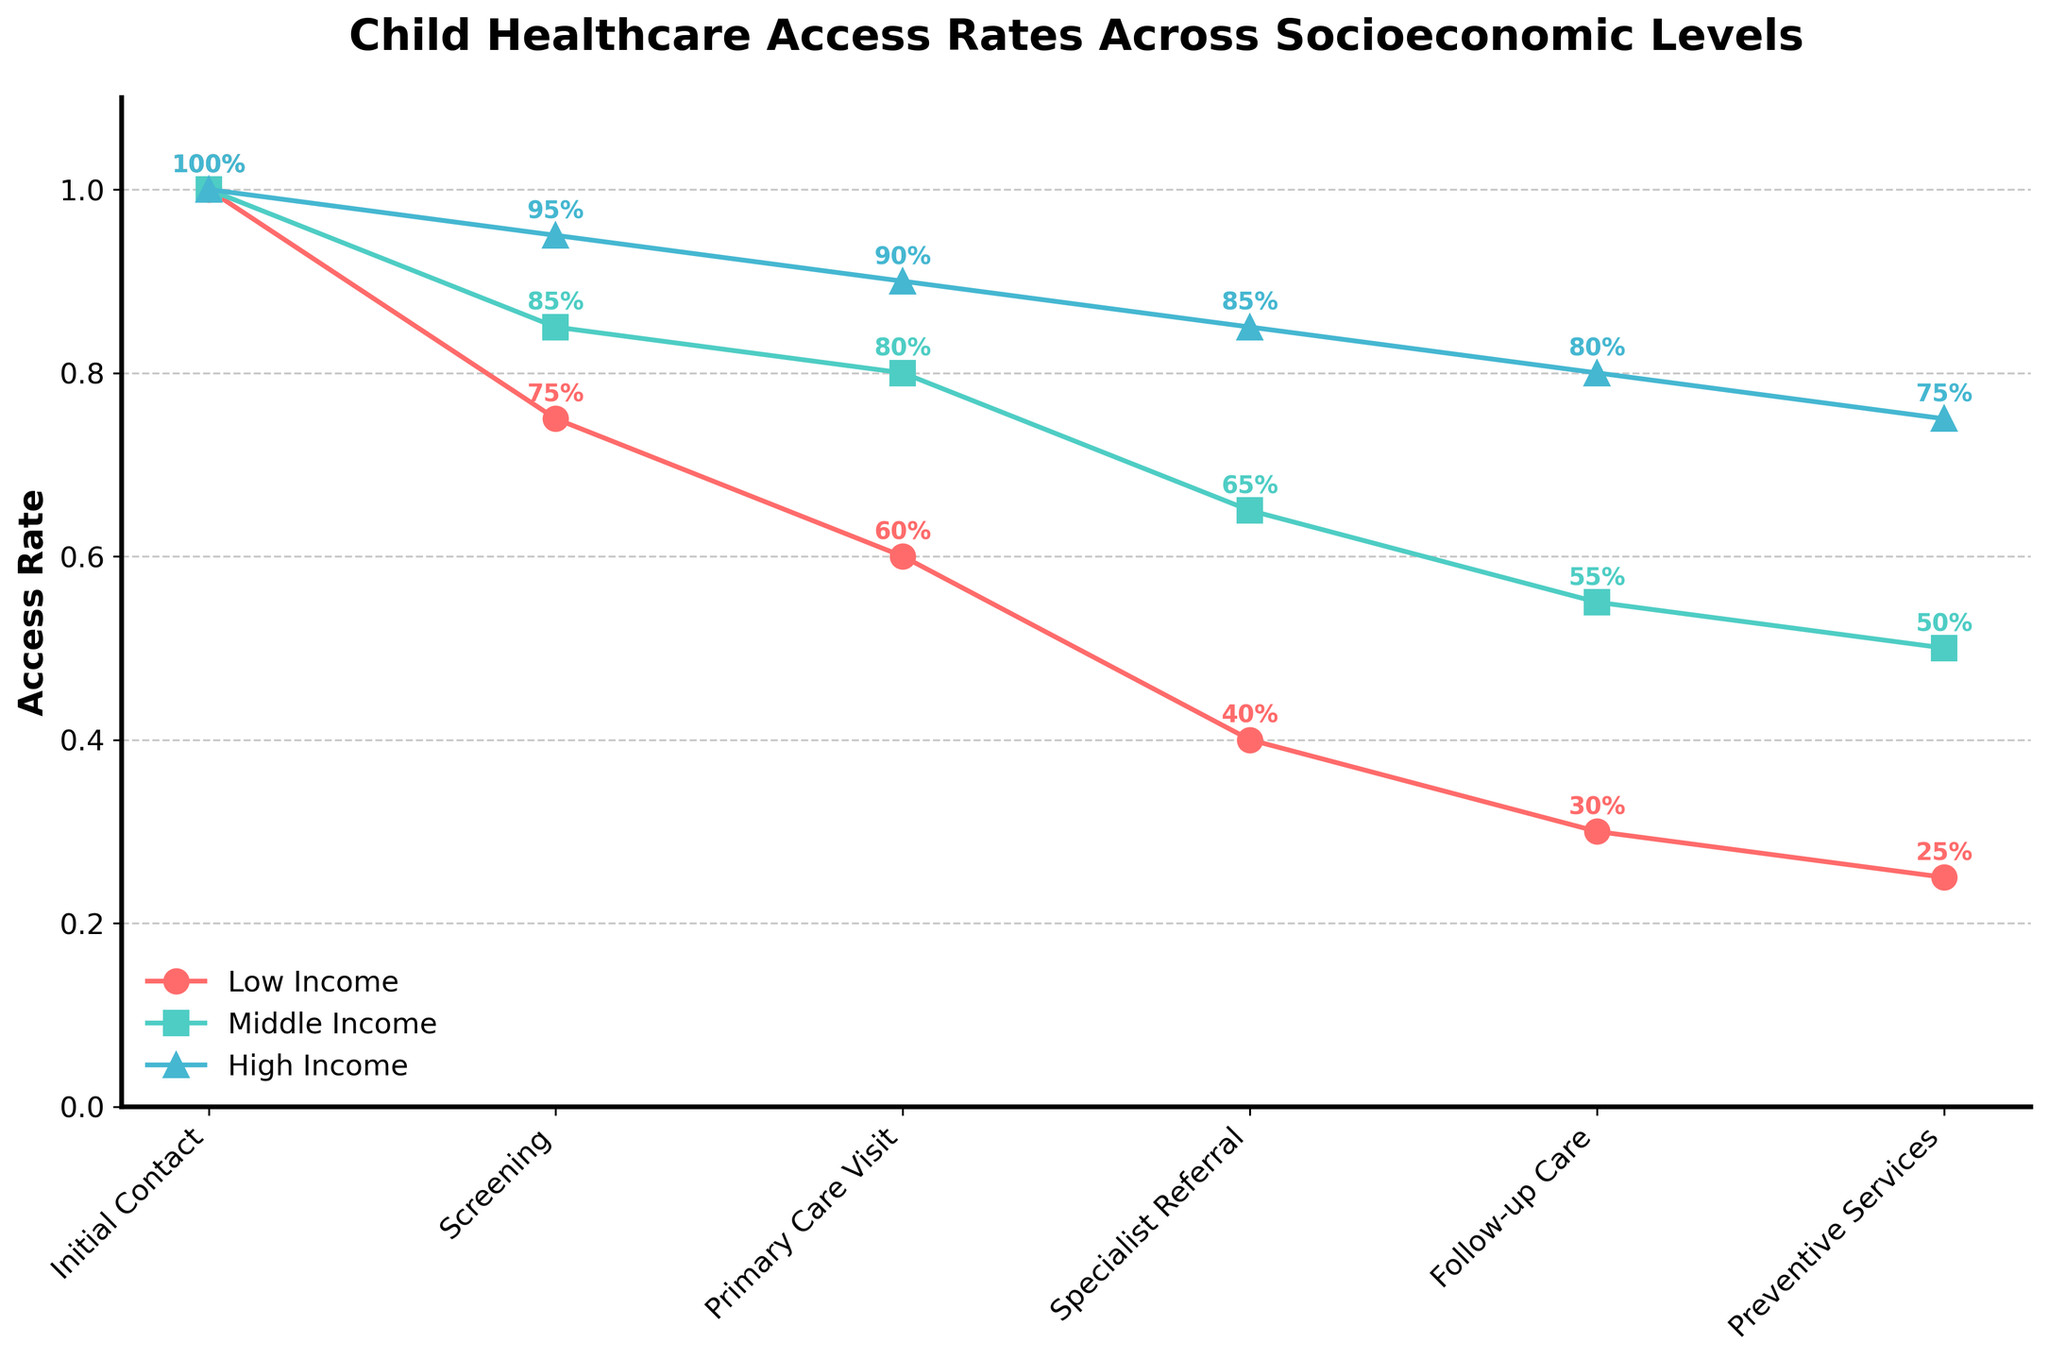What's the title of the figure? The title of the figure is displayed at the top and describes the content it represents. The title is "Child Healthcare Access Rates Across Socioeconomic Levels"
Answer: Child Healthcare Access Rates Across Socioeconomic Levels Which socioeconomic level has the lowest access rate at the Initial Contact stage? By examining the stage "Initial Contact" on the figure, the access rates are equal at 100% for Low Income, Middle Income, and High Income socioeconomic levels.
Answer: All are equal at 100% At the Specialist Referral stage, which socioeconomic group sees the greatest drop in access rate compared to the Primary Care Visit stage? The access rates for Low Income drop from 60% to 40%, Middle Income from 80% to 65%, and High Income from 90% to 85%. The greatest drop is seen in the Low Income group (20% drop).
Answer: Low Income What is the access rate for Preventive Services for High Income group? The access rate for Preventive Services for the High Income group can be found directly in the figure. It's located next to the "Preventive Services" stage marked with a shape for High Income.
Answer: 75% How much does the access rate for Middle Income decrease from Screening to Primary Care Visit? The Middle Income access rate is 85% at Screening and decreases to 80% at Primary Care Visit. The decrease can be calculated as 85% - 80% = 5%.
Answer: 5% Compare the follow-up care access rates between Middle Income and Low Income groups. Which group has a higher rate, and by how much? The access rate at the "Follow-up Care" stage for Middle Income is 55%, while for Low Income, it's 30%. The difference is calculated as 55% - 30% = 25%, with Middle Income having the higher rate.
Answer: Middle Income by 25% What is the trend of access rates for the High Income group across all stages? The trend for the High Income group shows a decline across stages starting from Initial Contact (100%) down to Preventive Services (75%). The consistent decrease shows a pattern of drop-off at each stage.
Answer: Decreasing Calculate the average access rate for the Low Income group across all stages. Summing the access rates for Low Income across all stages (100%, 75%, 60%, 40%, 30%, 25%) gives 330%. Dividing by the number of stages (6) gives an average of 330/6 = 55%.
Answer: 55% Which stage shows the smallest gap in access rates between Low and High Income groups? By comparing the access rate gaps at each stage, the Screening stage has the smallest gap: 95% (High Income) - 75% (Low Income) = 20%.
Answer: Screening (20%) What percentage of Low Income children make it to the Specialist Referral stage? Referring to the Specialist Referral stage in the figure, the percentage for Low Income is annotated as 40%.
Answer: 40% 